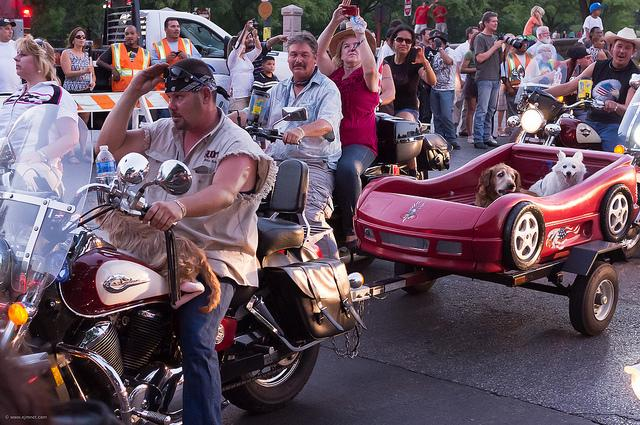The dogs face danger of falling off if the rider does what? drives fast 